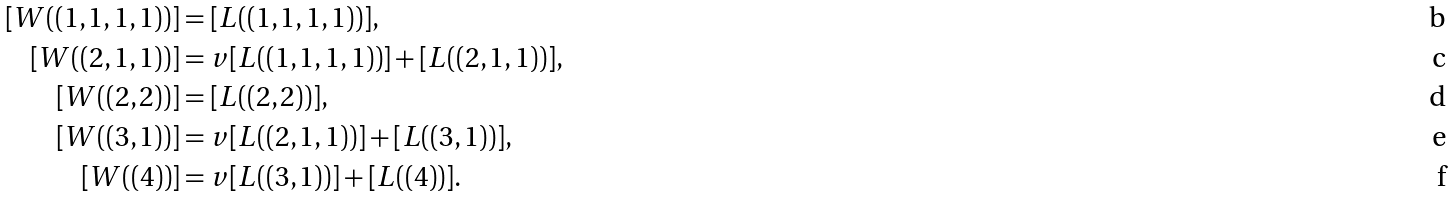<formula> <loc_0><loc_0><loc_500><loc_500>[ W ( ( 1 , 1 , 1 , 1 ) ) ] & = [ L ( ( 1 , 1 , 1 , 1 ) ) ] , \\ [ W ( ( 2 , 1 , 1 ) ) ] & = v [ L ( ( 1 , 1 , 1 , 1 ) ) ] + [ L ( ( 2 , 1 , 1 ) ) ] , \\ [ W ( ( 2 , 2 ) ) ] & = [ L ( ( 2 , 2 ) ) ] , \\ [ W ( ( 3 , 1 ) ) ] & = v [ L ( ( 2 , 1 , 1 ) ) ] + [ L ( ( 3 , 1 ) ) ] , \\ [ W ( ( 4 ) ) ] & = v [ L ( ( 3 , 1 ) ) ] + [ L ( ( 4 ) ) ] .</formula> 